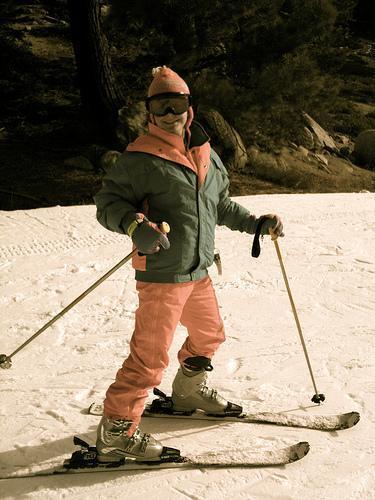How many people are there?
Give a very brief answer. 1. 